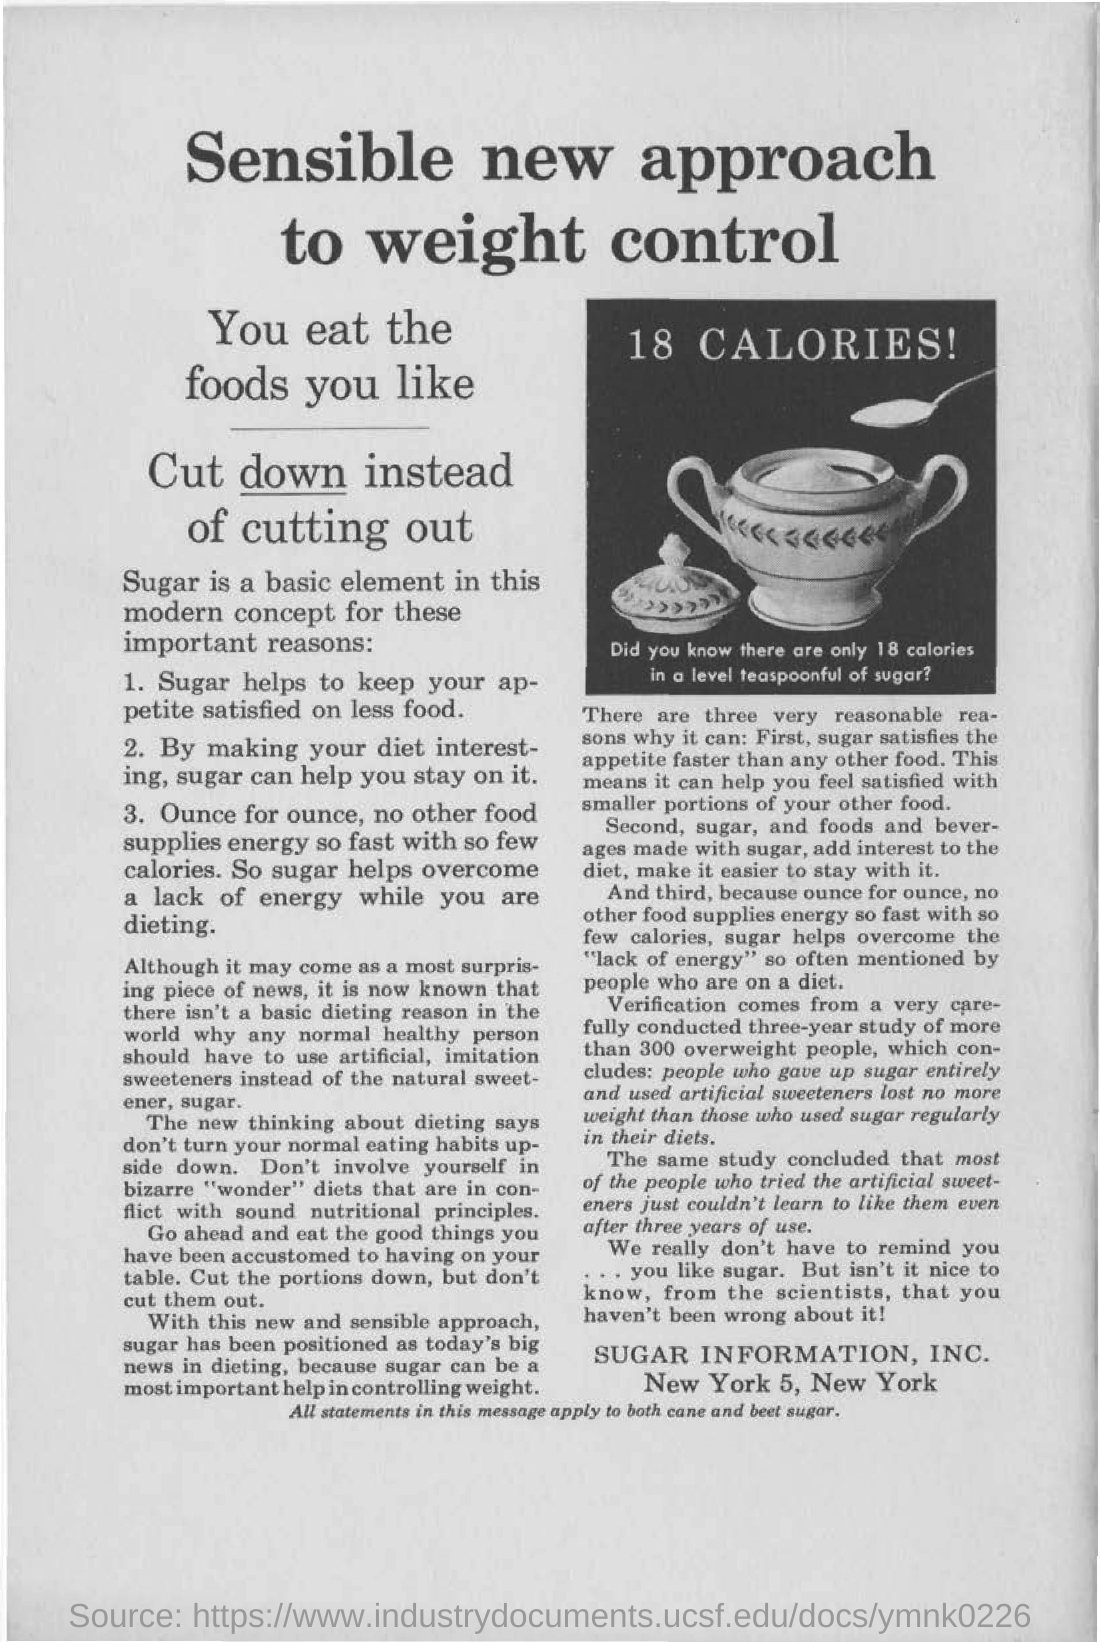Give some essential details in this illustration. This document introduces a revolutionary approach to weight control, known as the sensible new approach. There are 18 calories in a level teaspoonful of sugar. The main heading in the document is "A Sensible New Approach to Weight Control. The number of calories written in the image is 18 CALORIES! 